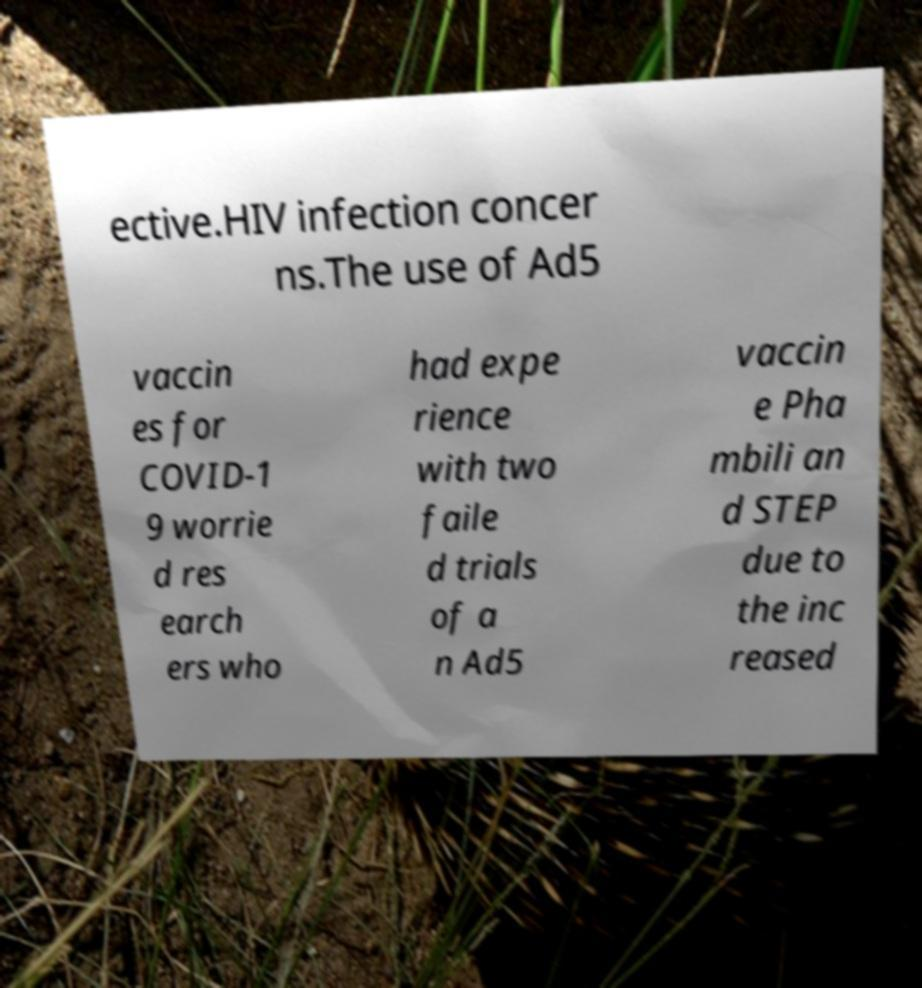For documentation purposes, I need the text within this image transcribed. Could you provide that? ective.HIV infection concer ns.The use of Ad5 vaccin es for COVID-1 9 worrie d res earch ers who had expe rience with two faile d trials of a n Ad5 vaccin e Pha mbili an d STEP due to the inc reased 